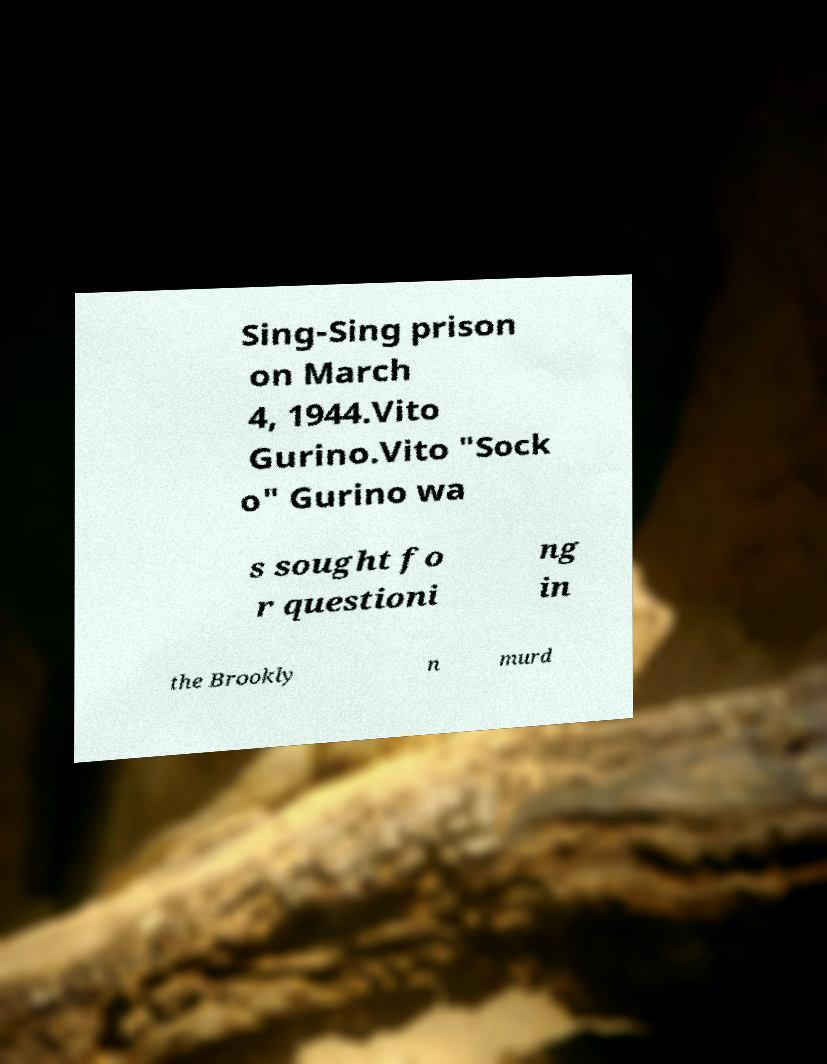For documentation purposes, I need the text within this image transcribed. Could you provide that? Sing-Sing prison on March 4, 1944.Vito Gurino.Vito "Sock o" Gurino wa s sought fo r questioni ng in the Brookly n murd 